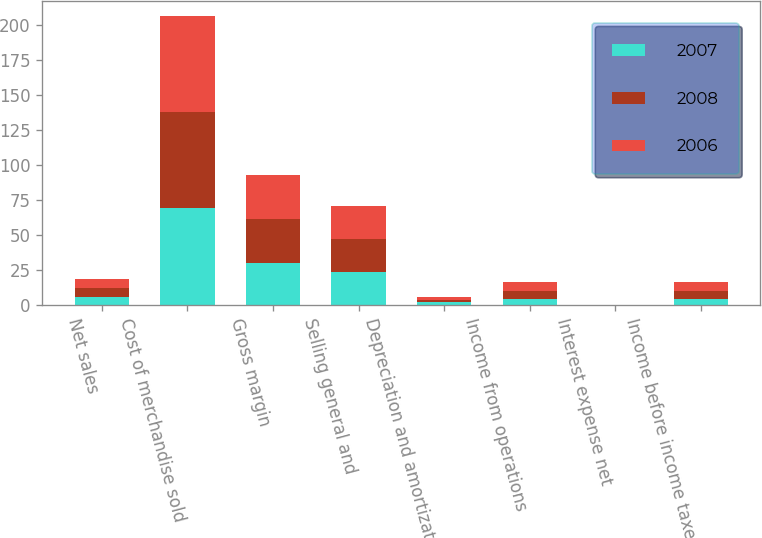Convert chart to OTSL. <chart><loc_0><loc_0><loc_500><loc_500><stacked_bar_chart><ecel><fcel>Net sales<fcel>Cost of merchandise sold<fcel>Gross margin<fcel>Selling general and<fcel>Depreciation and amortization<fcel>Income from operations<fcel>Interest expense net<fcel>Income before income taxes<nl><fcel>2007<fcel>6.1<fcel>69.7<fcel>30.3<fcel>23.8<fcel>2<fcel>4.5<fcel>0.1<fcel>4.4<nl><fcel>2008<fcel>6.1<fcel>68.5<fcel>31.5<fcel>23.7<fcel>1.9<fcel>5.9<fcel>0.2<fcel>5.7<nl><fcel>2006<fcel>6.1<fcel>68.5<fcel>31.5<fcel>23.5<fcel>1.8<fcel>6.2<fcel>0.1<fcel>6.1<nl></chart> 